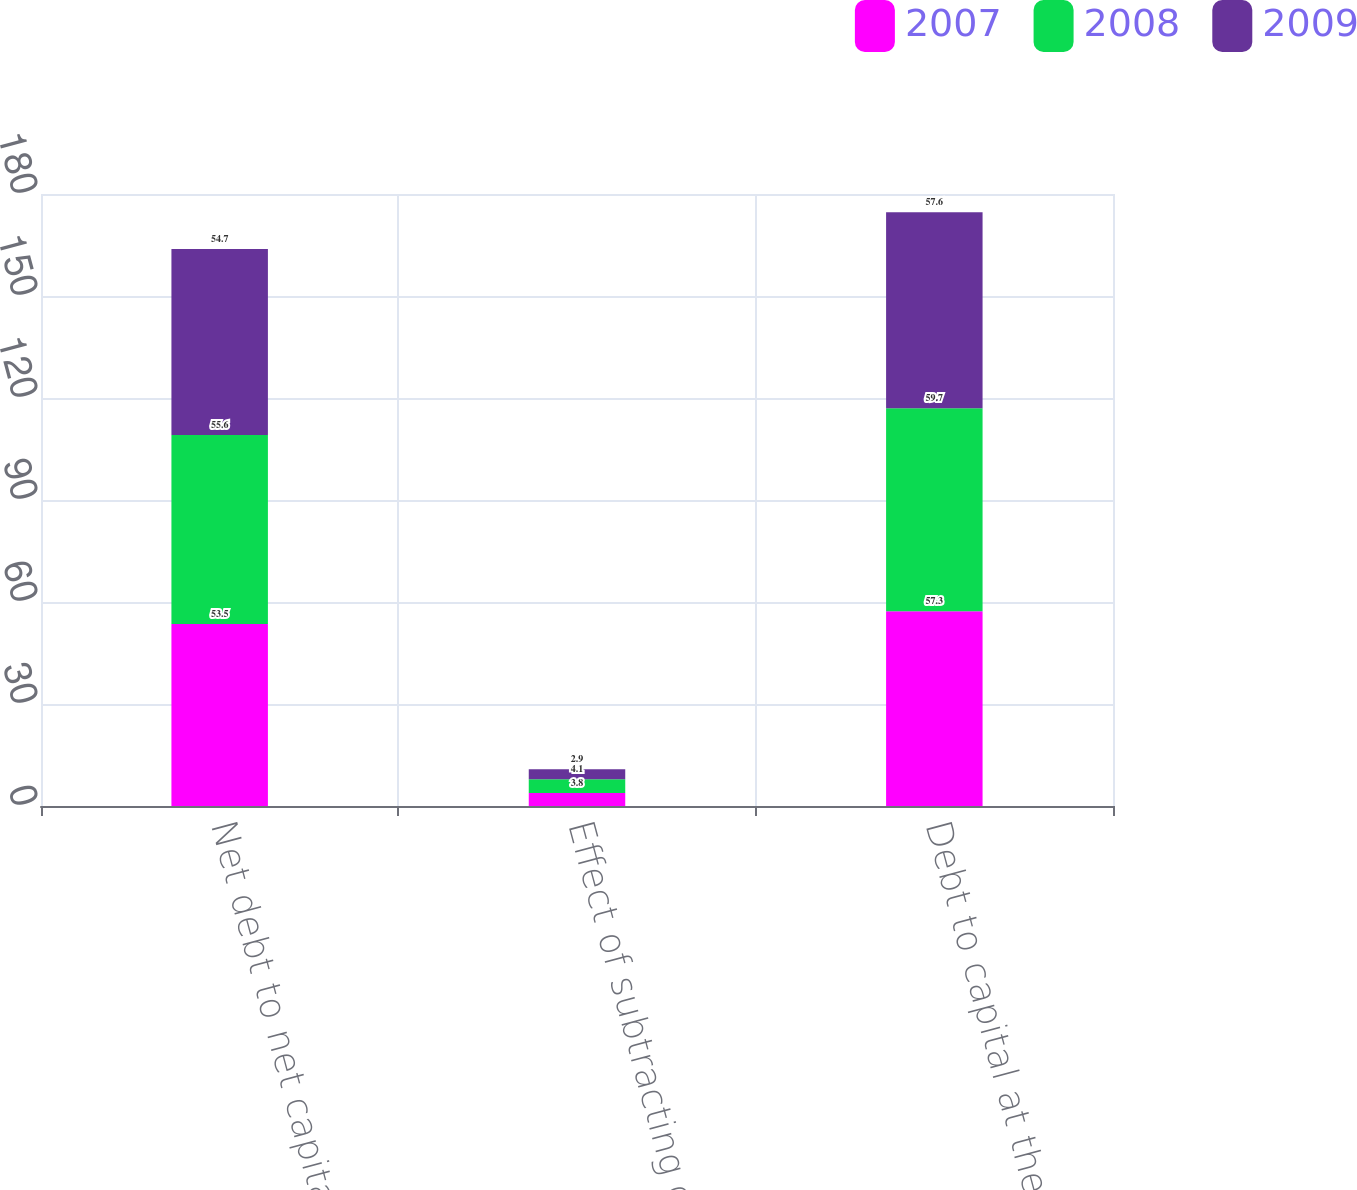Convert chart to OTSL. <chart><loc_0><loc_0><loc_500><loc_500><stacked_bar_chart><ecel><fcel>Net debt to net capital at the<fcel>Effect of subtracting cash<fcel>Debt to capital at the end of<nl><fcel>2007<fcel>53.5<fcel>3.8<fcel>57.3<nl><fcel>2008<fcel>55.6<fcel>4.1<fcel>59.7<nl><fcel>2009<fcel>54.7<fcel>2.9<fcel>57.6<nl></chart> 